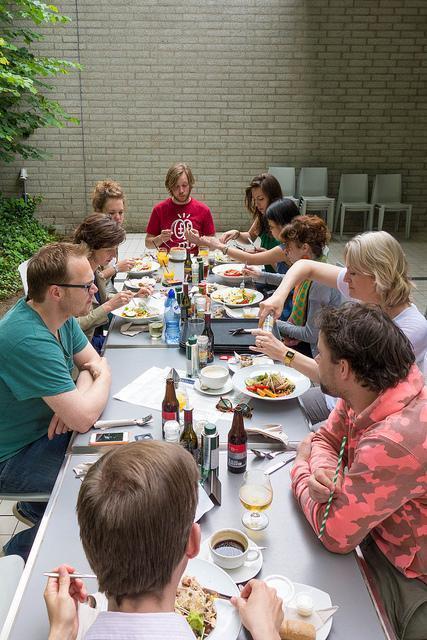Why does the person with the green shirt have no food?
Make your selection and explain in format: 'Answer: answer
Rationale: rationale.'
Options: Is through, is confused, is dieting, is sharing. Answer: is sharing.
Rationale: This person looks like they would like some of the food.  it is common for a person to refrain from eating in circumstances where they would normally eat if they are doing this. 